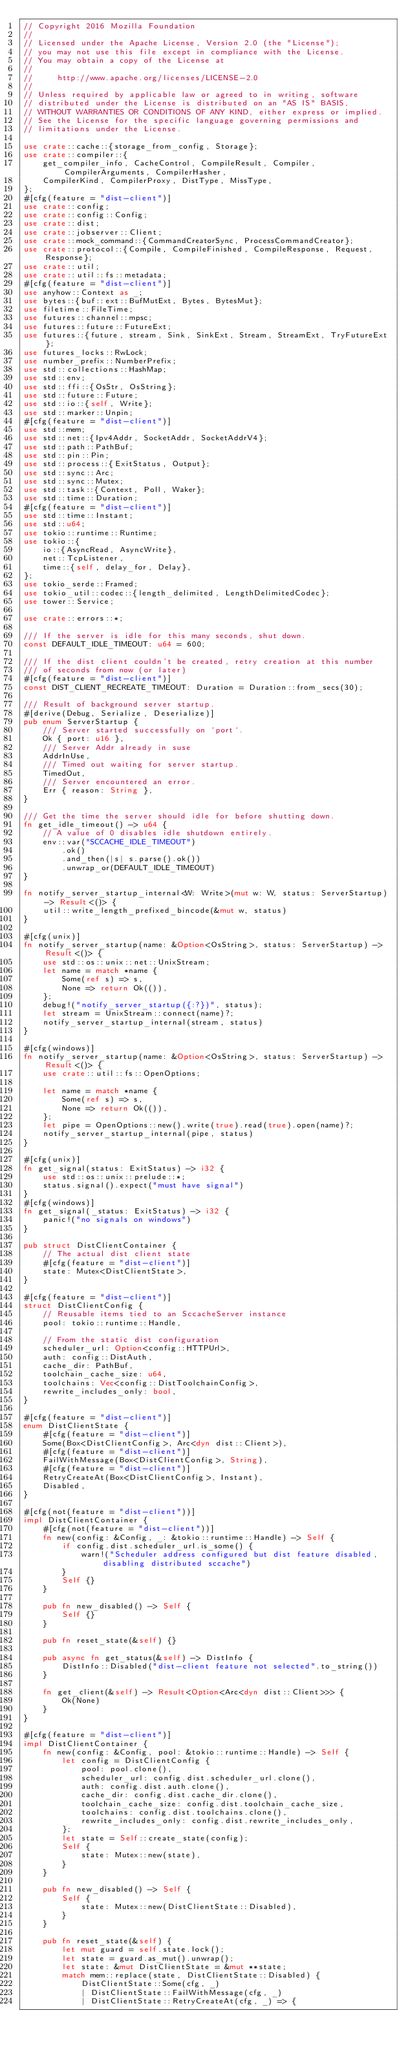Convert code to text. <code><loc_0><loc_0><loc_500><loc_500><_Rust_>// Copyright 2016 Mozilla Foundation
//
// Licensed under the Apache License, Version 2.0 (the "License");
// you may not use this file except in compliance with the License.
// You may obtain a copy of the License at
//
//     http://www.apache.org/licenses/LICENSE-2.0
//
// Unless required by applicable law or agreed to in writing, software
// distributed under the License is distributed on an "AS IS" BASIS,
// WITHOUT WARRANTIES OR CONDITIONS OF ANY KIND, either express or implied.
// See the License for the specific language governing permissions and
// limitations under the License.

use crate::cache::{storage_from_config, Storage};
use crate::compiler::{
    get_compiler_info, CacheControl, CompileResult, Compiler, CompilerArguments, CompilerHasher,
    CompilerKind, CompilerProxy, DistType, MissType,
};
#[cfg(feature = "dist-client")]
use crate::config;
use crate::config::Config;
use crate::dist;
use crate::jobserver::Client;
use crate::mock_command::{CommandCreatorSync, ProcessCommandCreator};
use crate::protocol::{Compile, CompileFinished, CompileResponse, Request, Response};
use crate::util;
use crate::util::fs::metadata;
#[cfg(feature = "dist-client")]
use anyhow::Context as _;
use bytes::{buf::ext::BufMutExt, Bytes, BytesMut};
use filetime::FileTime;
use futures::channel::mpsc;
use futures::future::FutureExt;
use futures::{future, stream, Sink, SinkExt, Stream, StreamExt, TryFutureExt};
use futures_locks::RwLock;
use number_prefix::NumberPrefix;
use std::collections::HashMap;
use std::env;
use std::ffi::{OsStr, OsString};
use std::future::Future;
use std::io::{self, Write};
use std::marker::Unpin;
#[cfg(feature = "dist-client")]
use std::mem;
use std::net::{Ipv4Addr, SocketAddr, SocketAddrV4};
use std::path::PathBuf;
use std::pin::Pin;
use std::process::{ExitStatus, Output};
use std::sync::Arc;
use std::sync::Mutex;
use std::task::{Context, Poll, Waker};
use std::time::Duration;
#[cfg(feature = "dist-client")]
use std::time::Instant;
use std::u64;
use tokio::runtime::Runtime;
use tokio::{
    io::{AsyncRead, AsyncWrite},
    net::TcpListener,
    time::{self, delay_for, Delay},
};
use tokio_serde::Framed;
use tokio_util::codec::{length_delimited, LengthDelimitedCodec};
use tower::Service;

use crate::errors::*;

/// If the server is idle for this many seconds, shut down.
const DEFAULT_IDLE_TIMEOUT: u64 = 600;

/// If the dist client couldn't be created, retry creation at this number
/// of seconds from now (or later)
#[cfg(feature = "dist-client")]
const DIST_CLIENT_RECREATE_TIMEOUT: Duration = Duration::from_secs(30);

/// Result of background server startup.
#[derive(Debug, Serialize, Deserialize)]
pub enum ServerStartup {
    /// Server started successfully on `port`.
    Ok { port: u16 },
    /// Server Addr already in suse
    AddrInUse,
    /// Timed out waiting for server startup.
    TimedOut,
    /// Server encountered an error.
    Err { reason: String },
}

/// Get the time the server should idle for before shutting down.
fn get_idle_timeout() -> u64 {
    // A value of 0 disables idle shutdown entirely.
    env::var("SCCACHE_IDLE_TIMEOUT")
        .ok()
        .and_then(|s| s.parse().ok())
        .unwrap_or(DEFAULT_IDLE_TIMEOUT)
}

fn notify_server_startup_internal<W: Write>(mut w: W, status: ServerStartup) -> Result<()> {
    util::write_length_prefixed_bincode(&mut w, status)
}

#[cfg(unix)]
fn notify_server_startup(name: &Option<OsString>, status: ServerStartup) -> Result<()> {
    use std::os::unix::net::UnixStream;
    let name = match *name {
        Some(ref s) => s,
        None => return Ok(()),
    };
    debug!("notify_server_startup({:?})", status);
    let stream = UnixStream::connect(name)?;
    notify_server_startup_internal(stream, status)
}

#[cfg(windows)]
fn notify_server_startup(name: &Option<OsString>, status: ServerStartup) -> Result<()> {
    use crate::util::fs::OpenOptions;

    let name = match *name {
        Some(ref s) => s,
        None => return Ok(()),
    };
    let pipe = OpenOptions::new().write(true).read(true).open(name)?;
    notify_server_startup_internal(pipe, status)
}

#[cfg(unix)]
fn get_signal(status: ExitStatus) -> i32 {
    use std::os::unix::prelude::*;
    status.signal().expect("must have signal")
}
#[cfg(windows)]
fn get_signal(_status: ExitStatus) -> i32 {
    panic!("no signals on windows")
}

pub struct DistClientContainer {
    // The actual dist client state
    #[cfg(feature = "dist-client")]
    state: Mutex<DistClientState>,
}

#[cfg(feature = "dist-client")]
struct DistClientConfig {
    // Reusable items tied to an SccacheServer instance
    pool: tokio::runtime::Handle,

    // From the static dist configuration
    scheduler_url: Option<config::HTTPUrl>,
    auth: config::DistAuth,
    cache_dir: PathBuf,
    toolchain_cache_size: u64,
    toolchains: Vec<config::DistToolchainConfig>,
    rewrite_includes_only: bool,
}

#[cfg(feature = "dist-client")]
enum DistClientState {
    #[cfg(feature = "dist-client")]
    Some(Box<DistClientConfig>, Arc<dyn dist::Client>),
    #[cfg(feature = "dist-client")]
    FailWithMessage(Box<DistClientConfig>, String),
    #[cfg(feature = "dist-client")]
    RetryCreateAt(Box<DistClientConfig>, Instant),
    Disabled,
}

#[cfg(not(feature = "dist-client"))]
impl DistClientContainer {
    #[cfg(not(feature = "dist-client"))]
    fn new(config: &Config, _: &tokio::runtime::Handle) -> Self {
        if config.dist.scheduler_url.is_some() {
            warn!("Scheduler address configured but dist feature disabled, disabling distributed sccache")
        }
        Self {}
    }

    pub fn new_disabled() -> Self {
        Self {}
    }

    pub fn reset_state(&self) {}

    pub async fn get_status(&self) -> DistInfo {
        DistInfo::Disabled("dist-client feature not selected".to_string())
    }

    fn get_client(&self) -> Result<Option<Arc<dyn dist::Client>>> {
        Ok(None)
    }
}

#[cfg(feature = "dist-client")]
impl DistClientContainer {
    fn new(config: &Config, pool: &tokio::runtime::Handle) -> Self {
        let config = DistClientConfig {
            pool: pool.clone(),
            scheduler_url: config.dist.scheduler_url.clone(),
            auth: config.dist.auth.clone(),
            cache_dir: config.dist.cache_dir.clone(),
            toolchain_cache_size: config.dist.toolchain_cache_size,
            toolchains: config.dist.toolchains.clone(),
            rewrite_includes_only: config.dist.rewrite_includes_only,
        };
        let state = Self::create_state(config);
        Self {
            state: Mutex::new(state),
        }
    }

    pub fn new_disabled() -> Self {
        Self {
            state: Mutex::new(DistClientState::Disabled),
        }
    }

    pub fn reset_state(&self) {
        let mut guard = self.state.lock();
        let state = guard.as_mut().unwrap();
        let state: &mut DistClientState = &mut **state;
        match mem::replace(state, DistClientState::Disabled) {
            DistClientState::Some(cfg, _)
            | DistClientState::FailWithMessage(cfg, _)
            | DistClientState::RetryCreateAt(cfg, _) => {</code> 